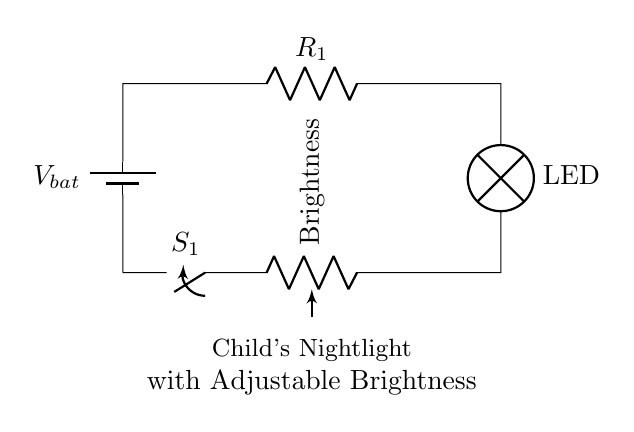What type of circuit is shown? This circuit is a series circuit because all components are connected end-to-end, forming one path for current flow.
Answer: Series circuit What component is used to adjust brightness? The component used is a potentiometer, which varies resistance and thus changes the brightness of the LED.
Answer: Potentiometer What is the role of the switch in this circuit? The switch, labeled S1, controls the flow of current; when closed, the circuit is complete and the nightlight turns on.
Answer: Control current What component converts electrical energy to light? The component that converts electrical energy to light is the lamp, specifically indicated as an LED in the circuit diagram.
Answer: LED If the resistance of R1 is 100 ohms, what will happen if it is increased? Increasing R1 will reduce the current flowing through the circuit, potentially dimming the LED if the circuit voltage remains constant.
Answer: Dimming LED What feature makes this nightlight suitable for children? The adjustable brightness feature allows parents to set a suitable light level for children, enhancing nighttime safety and comfort.
Answer: Adjustable brightness Which element provides the electrical power for the circuit? The battery, labeled Vbat in the circuit, supplies the electrical power needed for the circuit to operate.
Answer: Battery 